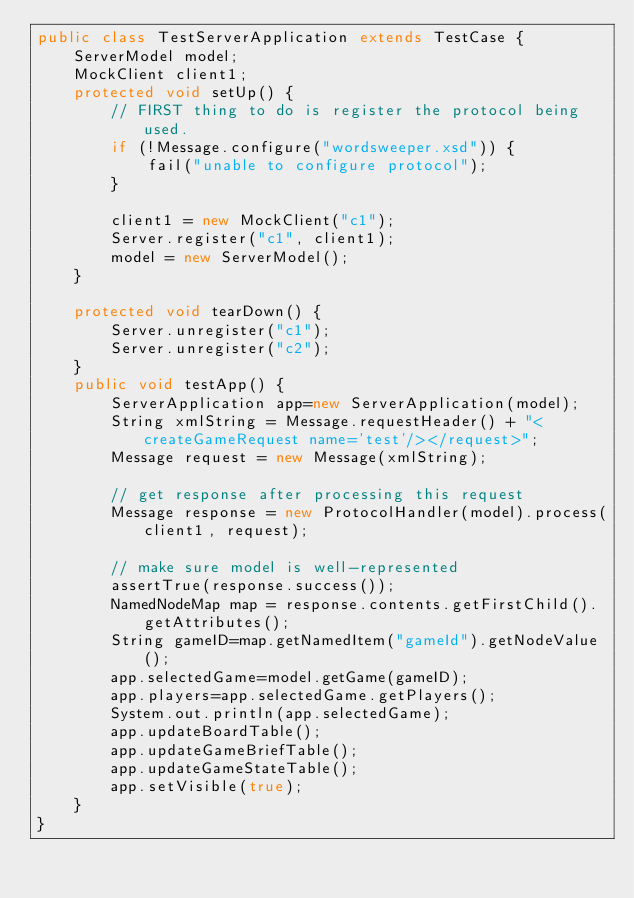Convert code to text. <code><loc_0><loc_0><loc_500><loc_500><_Java_>public class TestServerApplication extends TestCase {
    ServerModel model;
    MockClient client1;
    protected void setUp() {
        // FIRST thing to do is register the protocol being used.
        if (!Message.configure("wordsweeper.xsd")) {
            fail("unable to configure protocol");
        }

        client1 = new MockClient("c1");
        Server.register("c1", client1);
        model = new ServerModel();
    }

    protected void tearDown() {
        Server.unregister("c1");
        Server.unregister("c2");
    }
    public void testApp() {
        ServerApplication app=new ServerApplication(model);
        String xmlString = Message.requestHeader() + "<createGameRequest name='test'/></request>";
        Message request = new Message(xmlString);

        // get response after processing this request
        Message response = new ProtocolHandler(model).process(client1, request);

        // make sure model is well-represented
        assertTrue(response.success());
        NamedNodeMap map = response.contents.getFirstChild().getAttributes();
        String gameID=map.getNamedItem("gameId").getNodeValue();
        app.selectedGame=model.getGame(gameID);
        app.players=app.selectedGame.getPlayers();
        System.out.println(app.selectedGame);
        app.updateBoardTable();
        app.updateGameBriefTable();
        app.updateGameStateTable();
        app.setVisible(true);
    }
}

</code> 